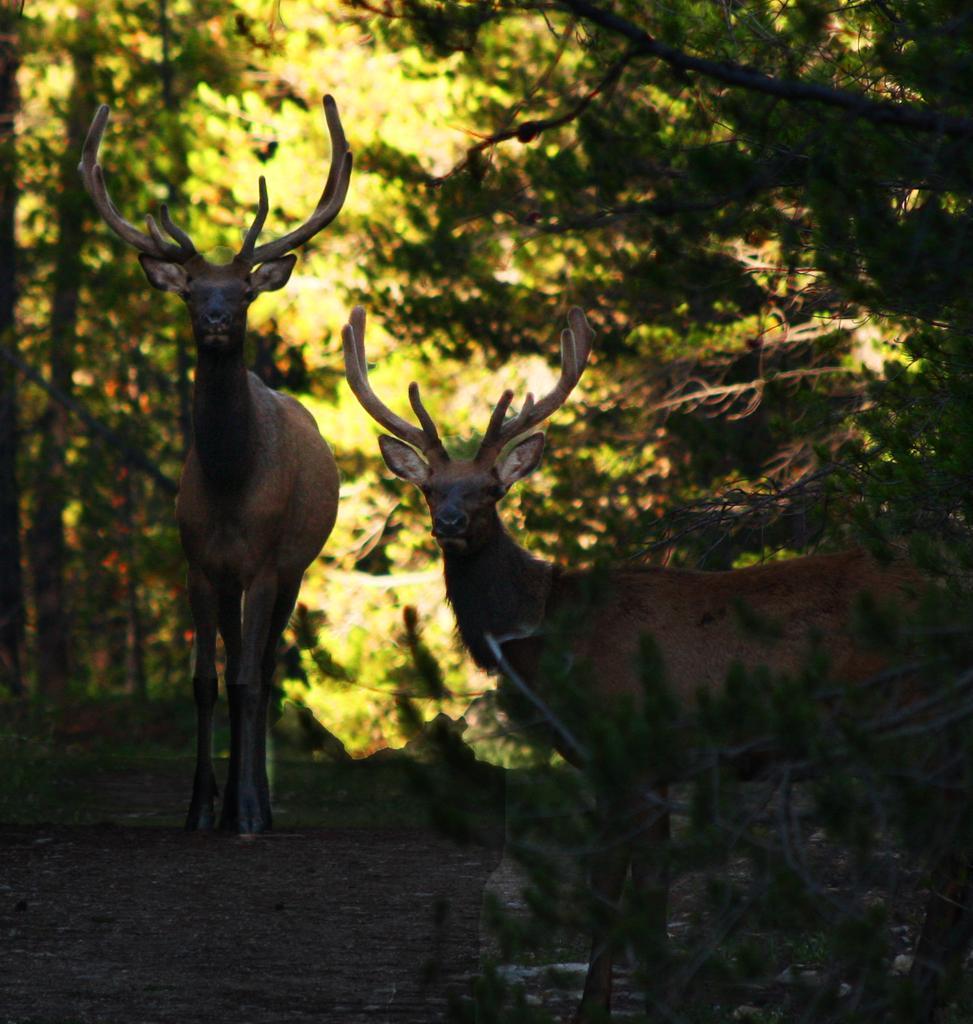How would you summarize this image in a sentence or two? Front we can see two animals. Background there are trees. 